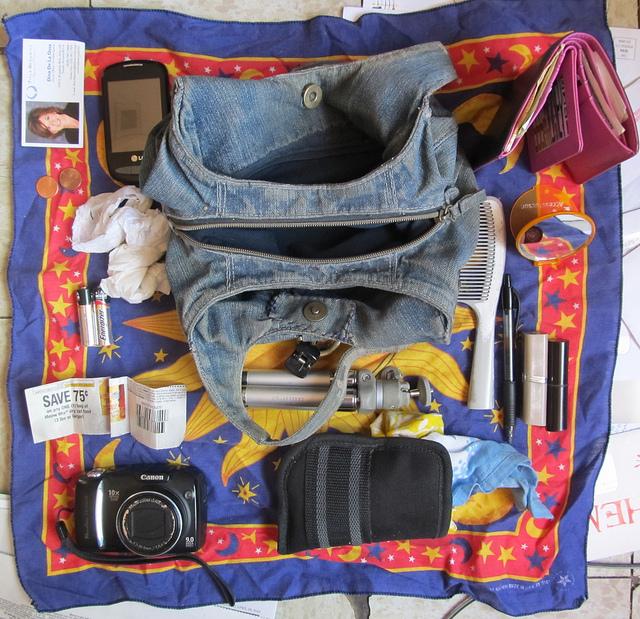What color is the wallet?
Give a very brief answer. Pink. What color is the comb in this picture?
Short answer required. White. Is the bag empty?
Concise answer only. Yes. 